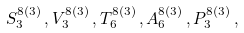Convert formula to latex. <formula><loc_0><loc_0><loc_500><loc_500>S ^ { 8 ( 3 ) } _ { 3 } \, , V ^ { 8 ( 3 ) } _ { 3 } \, , T ^ { 8 ( 3 ) } _ { 6 } \, , A ^ { 8 ( 3 ) } _ { 6 } \, , P ^ { 8 ( 3 ) } _ { 3 } \, ,</formula> 